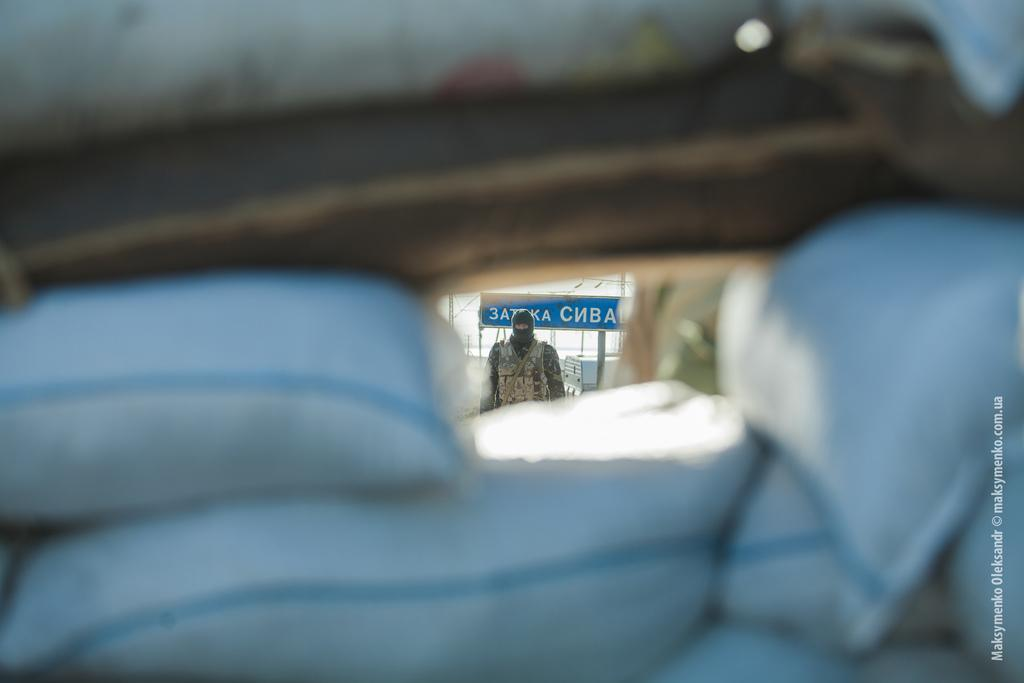What objects are present in the image? There are bags in the image. Can you describe the person in the image? There is a person standing in the image. What can be seen in the background of the image? There are poles, a building, and a board with text in the background of the image. What type of industry is being depicted in the image? There is no specific industry depicted in the image; it only shows bags, a person, poles, a building, and a board with text. How many times does the person turn around in the image? The person does not turn around in the image; they are simply standing. 